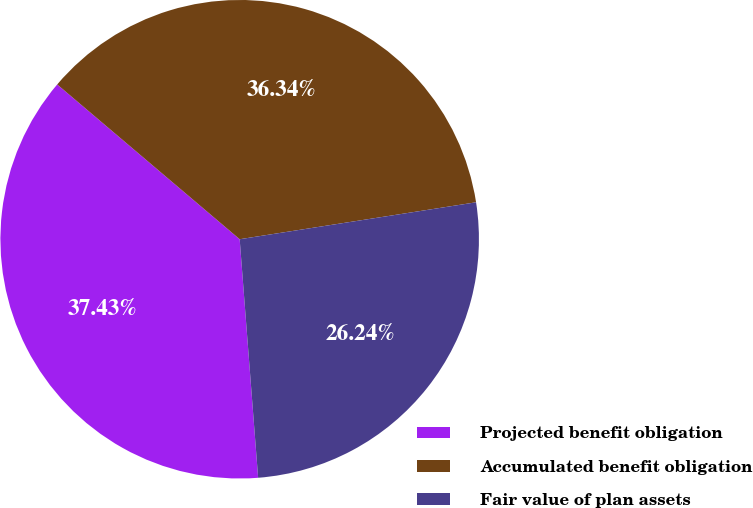<chart> <loc_0><loc_0><loc_500><loc_500><pie_chart><fcel>Projected benefit obligation<fcel>Accumulated benefit obligation<fcel>Fair value of plan assets<nl><fcel>37.43%<fcel>36.34%<fcel>26.24%<nl></chart> 